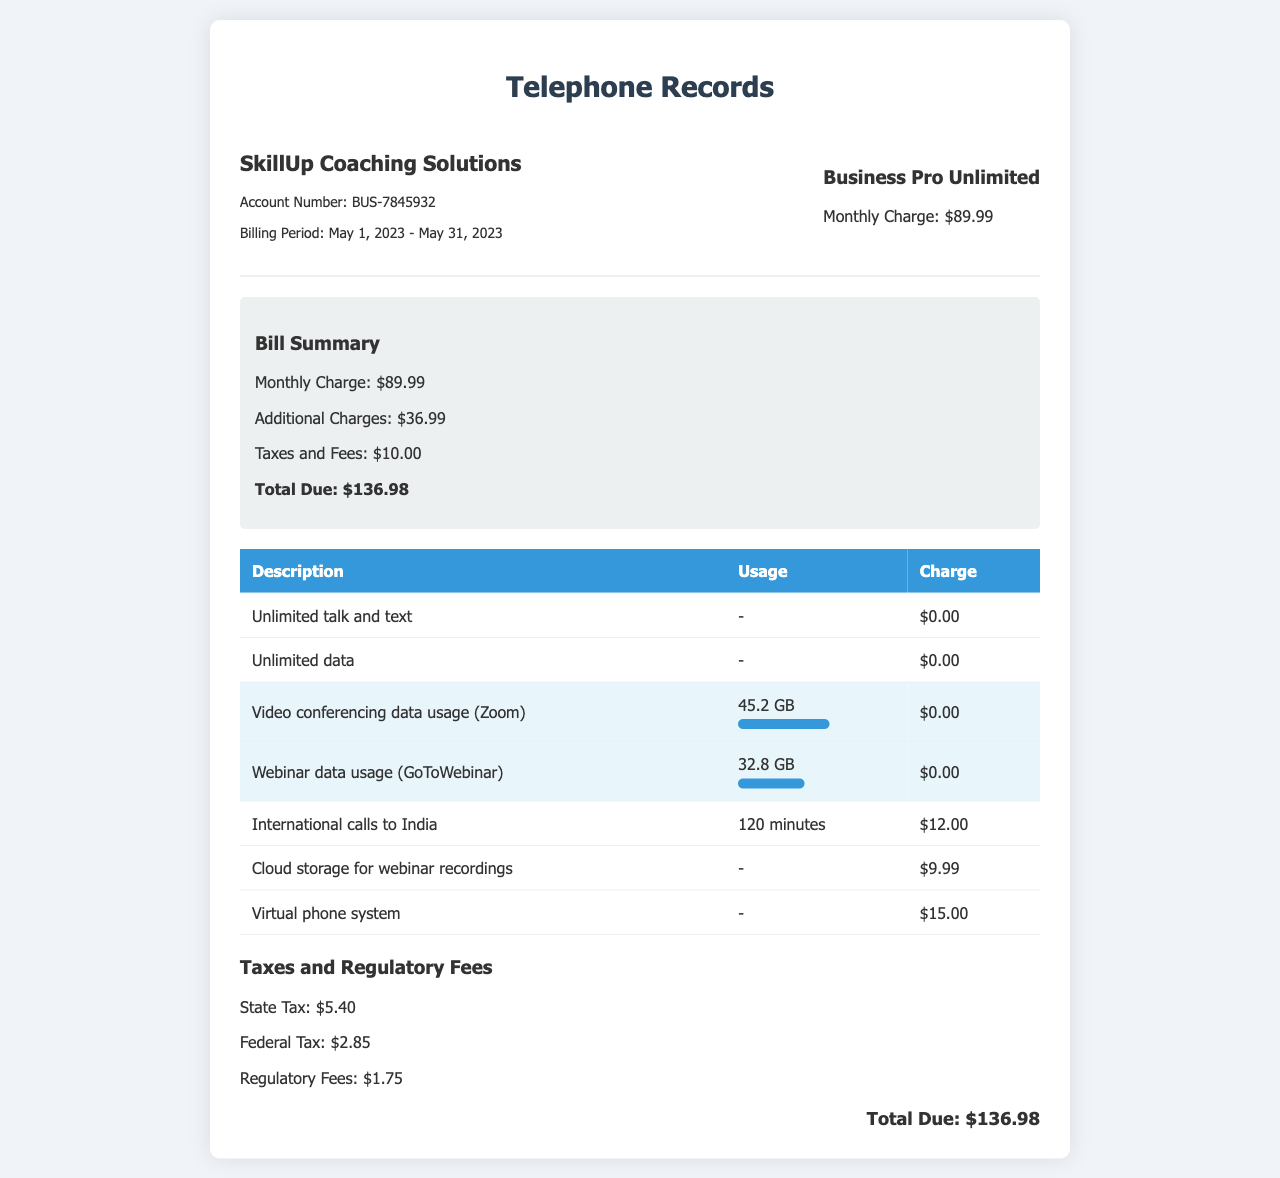What is the billing period? The billing period indicated in the document is from May 1, 2023 to May 31, 2023.
Answer: May 1, 2023 - May 31, 2023 What is the total due amount? The total due amount is the sum of monthly charges, additional charges, and taxes and fees, which totals $136.98.
Answer: $136.98 How much data was used for video conferencing? The document states the data usage for video conferencing (Zoom) is 45.2 GB.
Answer: 45.2 GB What is the charge for international calls to India? The charge for international calls to India is listed in the document as $12.00.
Answer: $12.00 What is the name of the phone plan? The phone plan mentioned in the document is called Business Pro Unlimited.
Answer: Business Pro Unlimited How much data was used for webinars? The data usage for webinars (GoToWebinar) is 32.8 GB, as specified in the document.
Answer: 32.8 GB What is the monthly charge for the business phone plan? The monthly charge for the business phone plan as listed in the document is $89.99.
Answer: $89.99 What fee is charged for cloud storage for webinar recordings? The fee for cloud storage for webinar recordings is noted as $9.99 in the document.
Answer: $9.99 What is the total of the taxes and regulatory fees? The total of the taxes (State Tax, Federal Tax, and Regulatory Fees) is $5.40 + $2.85 + $1.75, which equals $10.00.
Answer: $10.00 